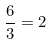Convert formula to latex. <formula><loc_0><loc_0><loc_500><loc_500>\frac { 6 } { 3 } = 2</formula> 